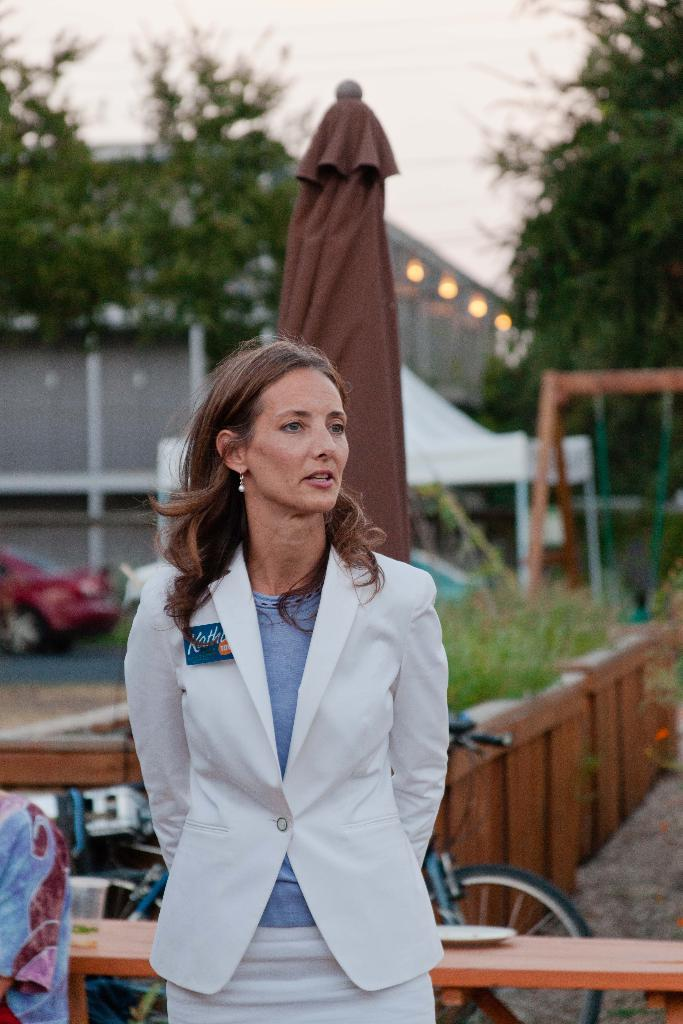Who is the main subject in the image? There is a lady in the image. What is the lady wearing? The lady is wearing a white dress. Where is the lady located in relation to the tent? The lady is standing behind a closed tent. What can be seen on the road in the image? There is a car on the road in the image. What type of structure is present in the image? There is a building in the image. What type of natural elements can be seen in the image? There are trees in the image. What is the lady teaching in the image? There is no indication in the image that the lady is teaching anything. 